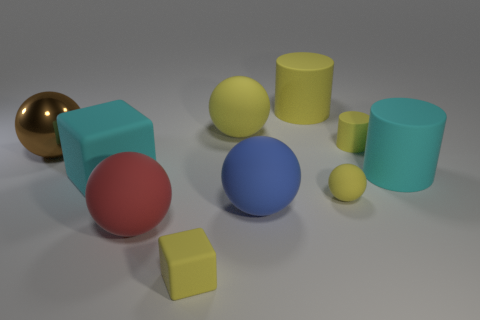How many other things are made of the same material as the cyan cylinder?
Give a very brief answer. 8. Is the shape of the large cyan object that is left of the small yellow cube the same as  the big blue rubber object?
Offer a terse response. No. How many small objects are either cyan cylinders or blue matte spheres?
Your response must be concise. 0. Are there an equal number of red rubber balls that are behind the blue thing and tiny balls that are to the right of the large cyan cube?
Keep it short and to the point. No. What number of other objects are the same color as the big shiny thing?
Make the answer very short. 0. There is a tiny cube; does it have the same color as the large cylinder left of the tiny yellow ball?
Provide a succinct answer. Yes. What number of yellow things are either small rubber spheres or spheres?
Your answer should be very brief. 2. Is the number of blue rubber things that are in front of the big blue rubber thing the same as the number of yellow matte balls?
Give a very brief answer. No. Are there any other things that are the same size as the cyan matte cylinder?
Make the answer very short. Yes. There is a tiny matte object that is the same shape as the brown shiny thing; what color is it?
Your answer should be very brief. Yellow. 